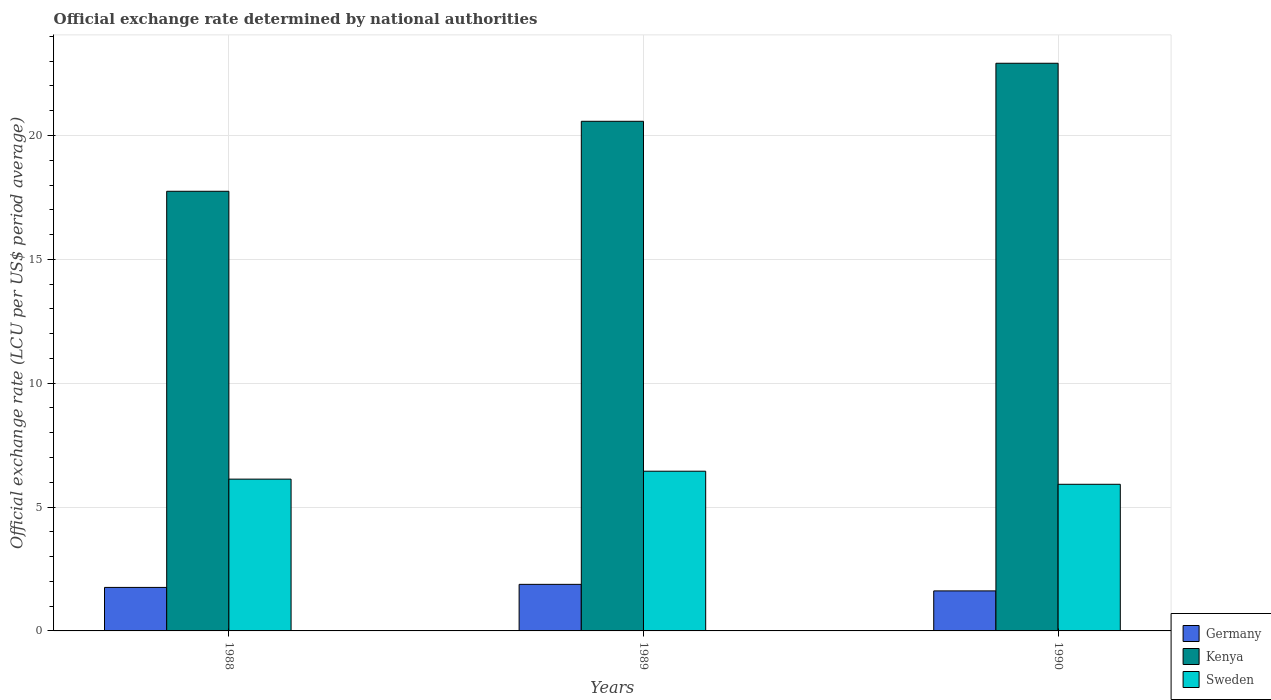How many groups of bars are there?
Give a very brief answer. 3. How many bars are there on the 1st tick from the left?
Offer a very short reply. 3. How many bars are there on the 3rd tick from the right?
Provide a short and direct response. 3. In how many cases, is the number of bars for a given year not equal to the number of legend labels?
Your answer should be very brief. 0. What is the official exchange rate in Germany in 1988?
Provide a short and direct response. 1.76. Across all years, what is the maximum official exchange rate in Sweden?
Your answer should be very brief. 6.45. Across all years, what is the minimum official exchange rate in Germany?
Your answer should be compact. 1.62. What is the total official exchange rate in Sweden in the graph?
Your answer should be very brief. 18.49. What is the difference between the official exchange rate in Kenya in 1988 and that in 1990?
Your answer should be very brief. -5.17. What is the difference between the official exchange rate in Sweden in 1988 and the official exchange rate in Kenya in 1989?
Keep it short and to the point. -14.45. What is the average official exchange rate in Sweden per year?
Your answer should be very brief. 6.16. In the year 1988, what is the difference between the official exchange rate in Kenya and official exchange rate in Sweden?
Provide a short and direct response. 11.62. In how many years, is the official exchange rate in Kenya greater than 14 LCU?
Offer a terse response. 3. What is the ratio of the official exchange rate in Kenya in 1988 to that in 1990?
Provide a succinct answer. 0.77. Is the official exchange rate in Germany in 1989 less than that in 1990?
Offer a very short reply. No. Is the difference between the official exchange rate in Kenya in 1988 and 1990 greater than the difference between the official exchange rate in Sweden in 1988 and 1990?
Give a very brief answer. No. What is the difference between the highest and the second highest official exchange rate in Kenya?
Provide a short and direct response. 2.34. What is the difference between the highest and the lowest official exchange rate in Kenya?
Your answer should be compact. 5.17. Is the sum of the official exchange rate in Kenya in 1988 and 1990 greater than the maximum official exchange rate in Sweden across all years?
Your response must be concise. Yes. What does the 1st bar from the left in 1990 represents?
Ensure brevity in your answer.  Germany. Are all the bars in the graph horizontal?
Provide a succinct answer. No. What is the difference between two consecutive major ticks on the Y-axis?
Provide a short and direct response. 5. Are the values on the major ticks of Y-axis written in scientific E-notation?
Provide a succinct answer. No. Does the graph contain any zero values?
Keep it short and to the point. No. What is the title of the graph?
Make the answer very short. Official exchange rate determined by national authorities. Does "Japan" appear as one of the legend labels in the graph?
Keep it short and to the point. No. What is the label or title of the Y-axis?
Provide a succinct answer. Official exchange rate (LCU per US$ period average). What is the Official exchange rate (LCU per US$ period average) in Germany in 1988?
Your response must be concise. 1.76. What is the Official exchange rate (LCU per US$ period average) of Kenya in 1988?
Offer a terse response. 17.75. What is the Official exchange rate (LCU per US$ period average) in Sweden in 1988?
Offer a very short reply. 6.13. What is the Official exchange rate (LCU per US$ period average) in Germany in 1989?
Give a very brief answer. 1.88. What is the Official exchange rate (LCU per US$ period average) of Kenya in 1989?
Your response must be concise. 20.57. What is the Official exchange rate (LCU per US$ period average) in Sweden in 1989?
Provide a succinct answer. 6.45. What is the Official exchange rate (LCU per US$ period average) of Germany in 1990?
Provide a succinct answer. 1.62. What is the Official exchange rate (LCU per US$ period average) of Kenya in 1990?
Offer a very short reply. 22.91. What is the Official exchange rate (LCU per US$ period average) in Sweden in 1990?
Your answer should be compact. 5.92. Across all years, what is the maximum Official exchange rate (LCU per US$ period average) of Germany?
Make the answer very short. 1.88. Across all years, what is the maximum Official exchange rate (LCU per US$ period average) of Kenya?
Keep it short and to the point. 22.91. Across all years, what is the maximum Official exchange rate (LCU per US$ period average) of Sweden?
Ensure brevity in your answer.  6.45. Across all years, what is the minimum Official exchange rate (LCU per US$ period average) in Germany?
Your answer should be very brief. 1.62. Across all years, what is the minimum Official exchange rate (LCU per US$ period average) of Kenya?
Ensure brevity in your answer.  17.75. Across all years, what is the minimum Official exchange rate (LCU per US$ period average) in Sweden?
Provide a short and direct response. 5.92. What is the total Official exchange rate (LCU per US$ period average) of Germany in the graph?
Your response must be concise. 5.25. What is the total Official exchange rate (LCU per US$ period average) in Kenya in the graph?
Make the answer very short. 61.23. What is the total Official exchange rate (LCU per US$ period average) in Sweden in the graph?
Provide a succinct answer. 18.49. What is the difference between the Official exchange rate (LCU per US$ period average) of Germany in 1988 and that in 1989?
Keep it short and to the point. -0.12. What is the difference between the Official exchange rate (LCU per US$ period average) in Kenya in 1988 and that in 1989?
Your answer should be very brief. -2.83. What is the difference between the Official exchange rate (LCU per US$ period average) of Sweden in 1988 and that in 1989?
Provide a succinct answer. -0.32. What is the difference between the Official exchange rate (LCU per US$ period average) in Germany in 1988 and that in 1990?
Offer a terse response. 0.14. What is the difference between the Official exchange rate (LCU per US$ period average) of Kenya in 1988 and that in 1990?
Ensure brevity in your answer.  -5.17. What is the difference between the Official exchange rate (LCU per US$ period average) of Sweden in 1988 and that in 1990?
Keep it short and to the point. 0.21. What is the difference between the Official exchange rate (LCU per US$ period average) of Germany in 1989 and that in 1990?
Provide a succinct answer. 0.26. What is the difference between the Official exchange rate (LCU per US$ period average) of Kenya in 1989 and that in 1990?
Offer a very short reply. -2.34. What is the difference between the Official exchange rate (LCU per US$ period average) in Sweden in 1989 and that in 1990?
Offer a terse response. 0.53. What is the difference between the Official exchange rate (LCU per US$ period average) of Germany in 1988 and the Official exchange rate (LCU per US$ period average) of Kenya in 1989?
Give a very brief answer. -18.82. What is the difference between the Official exchange rate (LCU per US$ period average) of Germany in 1988 and the Official exchange rate (LCU per US$ period average) of Sweden in 1989?
Keep it short and to the point. -4.69. What is the difference between the Official exchange rate (LCU per US$ period average) in Kenya in 1988 and the Official exchange rate (LCU per US$ period average) in Sweden in 1989?
Provide a succinct answer. 11.3. What is the difference between the Official exchange rate (LCU per US$ period average) in Germany in 1988 and the Official exchange rate (LCU per US$ period average) in Kenya in 1990?
Offer a terse response. -21.16. What is the difference between the Official exchange rate (LCU per US$ period average) of Germany in 1988 and the Official exchange rate (LCU per US$ period average) of Sweden in 1990?
Your answer should be compact. -4.16. What is the difference between the Official exchange rate (LCU per US$ period average) in Kenya in 1988 and the Official exchange rate (LCU per US$ period average) in Sweden in 1990?
Your response must be concise. 11.83. What is the difference between the Official exchange rate (LCU per US$ period average) of Germany in 1989 and the Official exchange rate (LCU per US$ period average) of Kenya in 1990?
Your answer should be compact. -21.03. What is the difference between the Official exchange rate (LCU per US$ period average) in Germany in 1989 and the Official exchange rate (LCU per US$ period average) in Sweden in 1990?
Provide a short and direct response. -4.04. What is the difference between the Official exchange rate (LCU per US$ period average) in Kenya in 1989 and the Official exchange rate (LCU per US$ period average) in Sweden in 1990?
Your response must be concise. 14.65. What is the average Official exchange rate (LCU per US$ period average) of Germany per year?
Make the answer very short. 1.75. What is the average Official exchange rate (LCU per US$ period average) of Kenya per year?
Your answer should be very brief. 20.41. What is the average Official exchange rate (LCU per US$ period average) in Sweden per year?
Give a very brief answer. 6.16. In the year 1988, what is the difference between the Official exchange rate (LCU per US$ period average) of Germany and Official exchange rate (LCU per US$ period average) of Kenya?
Offer a terse response. -15.99. In the year 1988, what is the difference between the Official exchange rate (LCU per US$ period average) of Germany and Official exchange rate (LCU per US$ period average) of Sweden?
Provide a short and direct response. -4.37. In the year 1988, what is the difference between the Official exchange rate (LCU per US$ period average) of Kenya and Official exchange rate (LCU per US$ period average) of Sweden?
Keep it short and to the point. 11.62. In the year 1989, what is the difference between the Official exchange rate (LCU per US$ period average) of Germany and Official exchange rate (LCU per US$ period average) of Kenya?
Provide a short and direct response. -18.69. In the year 1989, what is the difference between the Official exchange rate (LCU per US$ period average) in Germany and Official exchange rate (LCU per US$ period average) in Sweden?
Offer a terse response. -4.57. In the year 1989, what is the difference between the Official exchange rate (LCU per US$ period average) of Kenya and Official exchange rate (LCU per US$ period average) of Sweden?
Ensure brevity in your answer.  14.13. In the year 1990, what is the difference between the Official exchange rate (LCU per US$ period average) of Germany and Official exchange rate (LCU per US$ period average) of Kenya?
Provide a succinct answer. -21.3. In the year 1990, what is the difference between the Official exchange rate (LCU per US$ period average) in Germany and Official exchange rate (LCU per US$ period average) in Sweden?
Give a very brief answer. -4.3. In the year 1990, what is the difference between the Official exchange rate (LCU per US$ period average) in Kenya and Official exchange rate (LCU per US$ period average) in Sweden?
Ensure brevity in your answer.  17. What is the ratio of the Official exchange rate (LCU per US$ period average) in Germany in 1988 to that in 1989?
Give a very brief answer. 0.93. What is the ratio of the Official exchange rate (LCU per US$ period average) in Kenya in 1988 to that in 1989?
Offer a terse response. 0.86. What is the ratio of the Official exchange rate (LCU per US$ period average) of Sweden in 1988 to that in 1989?
Your answer should be compact. 0.95. What is the ratio of the Official exchange rate (LCU per US$ period average) in Germany in 1988 to that in 1990?
Your answer should be compact. 1.09. What is the ratio of the Official exchange rate (LCU per US$ period average) in Kenya in 1988 to that in 1990?
Give a very brief answer. 0.77. What is the ratio of the Official exchange rate (LCU per US$ period average) of Sweden in 1988 to that in 1990?
Offer a very short reply. 1.04. What is the ratio of the Official exchange rate (LCU per US$ period average) in Germany in 1989 to that in 1990?
Offer a very short reply. 1.16. What is the ratio of the Official exchange rate (LCU per US$ period average) in Kenya in 1989 to that in 1990?
Your answer should be compact. 0.9. What is the ratio of the Official exchange rate (LCU per US$ period average) of Sweden in 1989 to that in 1990?
Make the answer very short. 1.09. What is the difference between the highest and the second highest Official exchange rate (LCU per US$ period average) in Germany?
Offer a very short reply. 0.12. What is the difference between the highest and the second highest Official exchange rate (LCU per US$ period average) in Kenya?
Offer a terse response. 2.34. What is the difference between the highest and the second highest Official exchange rate (LCU per US$ period average) in Sweden?
Your answer should be compact. 0.32. What is the difference between the highest and the lowest Official exchange rate (LCU per US$ period average) of Germany?
Ensure brevity in your answer.  0.26. What is the difference between the highest and the lowest Official exchange rate (LCU per US$ period average) in Kenya?
Provide a short and direct response. 5.17. What is the difference between the highest and the lowest Official exchange rate (LCU per US$ period average) in Sweden?
Provide a succinct answer. 0.53. 